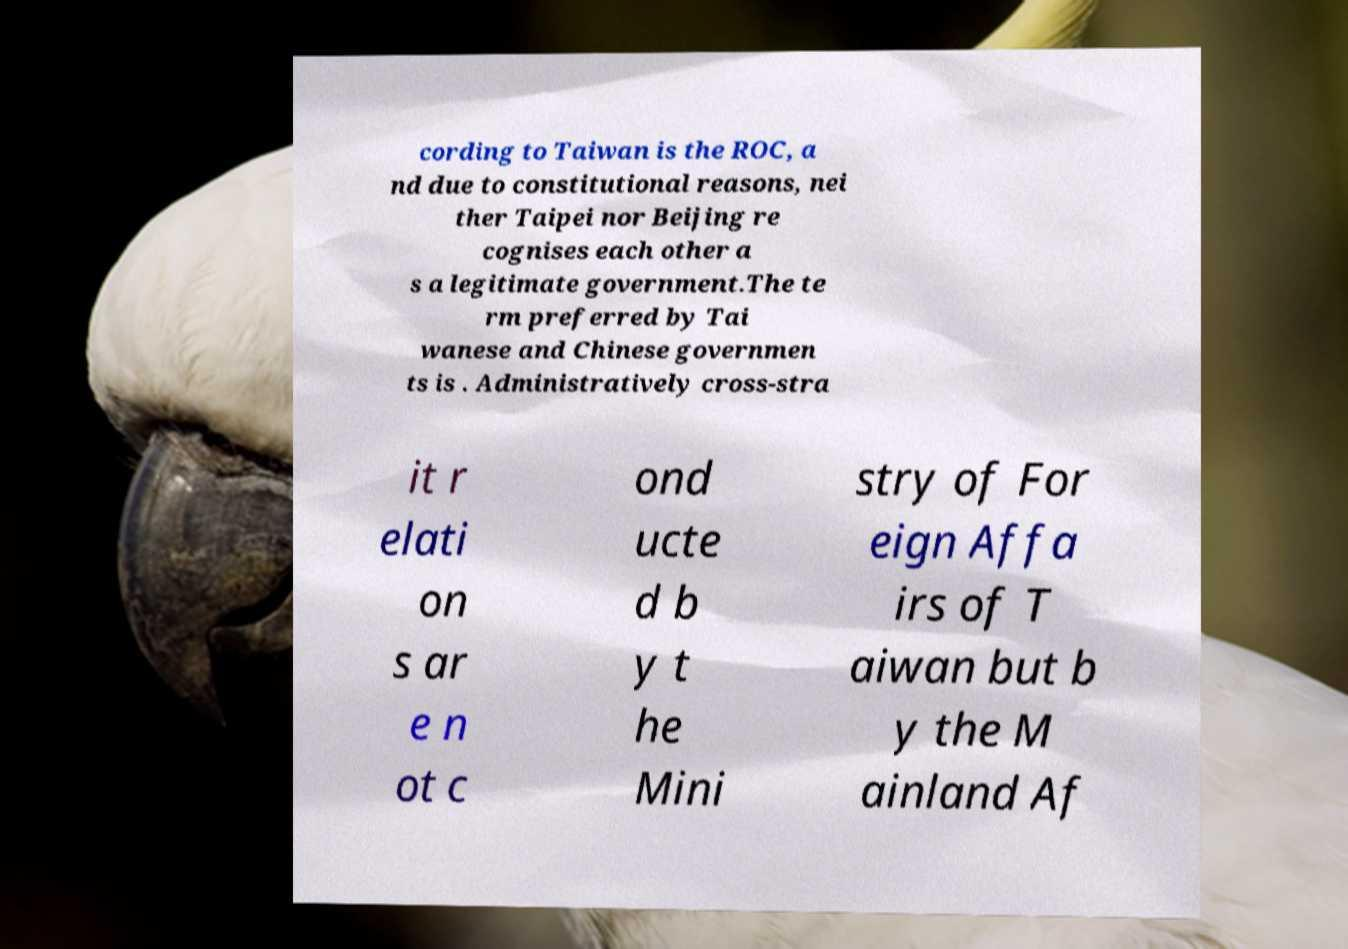Please identify and transcribe the text found in this image. cording to Taiwan is the ROC, a nd due to constitutional reasons, nei ther Taipei nor Beijing re cognises each other a s a legitimate government.The te rm preferred by Tai wanese and Chinese governmen ts is . Administratively cross-stra it r elati on s ar e n ot c ond ucte d b y t he Mini stry of For eign Affa irs of T aiwan but b y the M ainland Af 